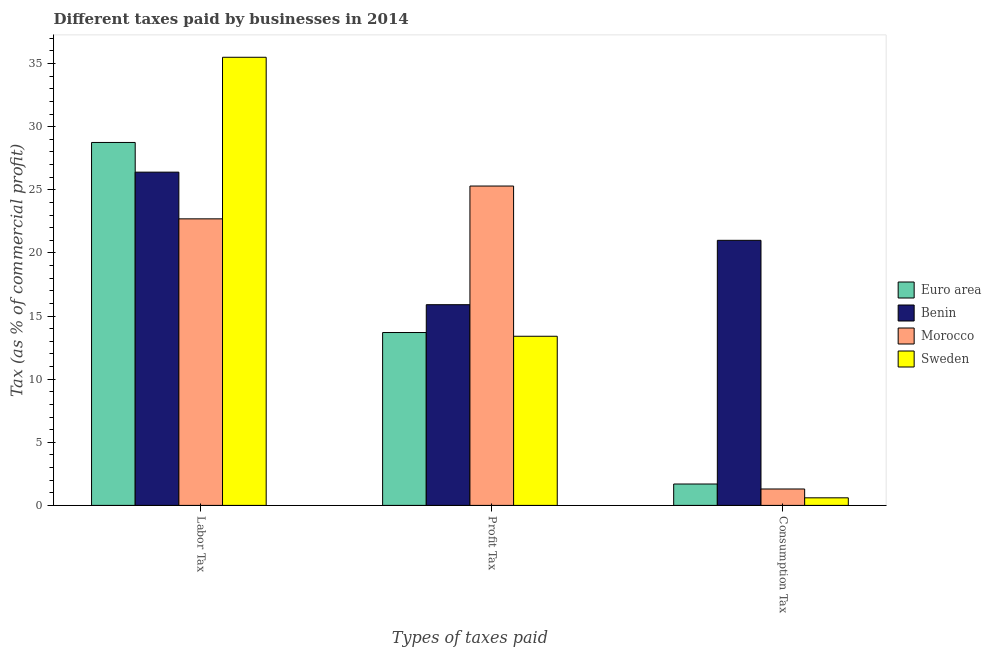Are the number of bars per tick equal to the number of legend labels?
Your response must be concise. Yes. How many bars are there on the 2nd tick from the left?
Offer a very short reply. 4. What is the label of the 3rd group of bars from the left?
Provide a succinct answer. Consumption Tax. What is the percentage of labor tax in Benin?
Give a very brief answer. 26.4. Across all countries, what is the minimum percentage of profit tax?
Give a very brief answer. 13.4. In which country was the percentage of profit tax maximum?
Keep it short and to the point. Morocco. What is the total percentage of consumption tax in the graph?
Your answer should be compact. 24.59. What is the difference between the percentage of profit tax in Sweden and that in Euro area?
Provide a short and direct response. -0.29. What is the difference between the percentage of profit tax in Sweden and the percentage of consumption tax in Morocco?
Your answer should be very brief. 12.1. What is the average percentage of labor tax per country?
Your answer should be compact. 28.34. What is the difference between the percentage of labor tax and percentage of profit tax in Morocco?
Make the answer very short. -2.6. In how many countries, is the percentage of profit tax greater than 19 %?
Your answer should be compact. 1. What is the ratio of the percentage of consumption tax in Sweden to that in Morocco?
Give a very brief answer. 0.46. Is the percentage of profit tax in Euro area less than that in Sweden?
Your answer should be compact. No. What is the difference between the highest and the second highest percentage of labor tax?
Provide a succinct answer. 6.75. What is the difference between the highest and the lowest percentage of labor tax?
Keep it short and to the point. 12.8. What does the 2nd bar from the left in Profit Tax represents?
Give a very brief answer. Benin. What does the 1st bar from the right in Labor Tax represents?
Your answer should be compact. Sweden. Is it the case that in every country, the sum of the percentage of labor tax and percentage of profit tax is greater than the percentage of consumption tax?
Your answer should be compact. Yes. How many bars are there?
Offer a terse response. 12. Are all the bars in the graph horizontal?
Your answer should be very brief. No. What is the difference between two consecutive major ticks on the Y-axis?
Your answer should be very brief. 5. Are the values on the major ticks of Y-axis written in scientific E-notation?
Your answer should be compact. No. Does the graph contain any zero values?
Provide a succinct answer. No. How are the legend labels stacked?
Offer a very short reply. Vertical. What is the title of the graph?
Offer a very short reply. Different taxes paid by businesses in 2014. What is the label or title of the X-axis?
Your answer should be very brief. Types of taxes paid. What is the label or title of the Y-axis?
Your response must be concise. Tax (as % of commercial profit). What is the Tax (as % of commercial profit) in Euro area in Labor Tax?
Provide a short and direct response. 28.75. What is the Tax (as % of commercial profit) in Benin in Labor Tax?
Your response must be concise. 26.4. What is the Tax (as % of commercial profit) in Morocco in Labor Tax?
Provide a short and direct response. 22.7. What is the Tax (as % of commercial profit) of Sweden in Labor Tax?
Your answer should be very brief. 35.5. What is the Tax (as % of commercial profit) of Euro area in Profit Tax?
Offer a terse response. 13.69. What is the Tax (as % of commercial profit) of Morocco in Profit Tax?
Ensure brevity in your answer.  25.3. What is the Tax (as % of commercial profit) in Sweden in Profit Tax?
Ensure brevity in your answer.  13.4. What is the Tax (as % of commercial profit) of Euro area in Consumption Tax?
Ensure brevity in your answer.  1.69. Across all Types of taxes paid, what is the maximum Tax (as % of commercial profit) of Euro area?
Offer a terse response. 28.75. Across all Types of taxes paid, what is the maximum Tax (as % of commercial profit) in Benin?
Make the answer very short. 26.4. Across all Types of taxes paid, what is the maximum Tax (as % of commercial profit) of Morocco?
Your response must be concise. 25.3. Across all Types of taxes paid, what is the maximum Tax (as % of commercial profit) in Sweden?
Offer a very short reply. 35.5. Across all Types of taxes paid, what is the minimum Tax (as % of commercial profit) of Euro area?
Ensure brevity in your answer.  1.69. Across all Types of taxes paid, what is the minimum Tax (as % of commercial profit) in Benin?
Ensure brevity in your answer.  15.9. Across all Types of taxes paid, what is the minimum Tax (as % of commercial profit) in Sweden?
Give a very brief answer. 0.6. What is the total Tax (as % of commercial profit) in Euro area in the graph?
Make the answer very short. 44.14. What is the total Tax (as % of commercial profit) of Benin in the graph?
Your answer should be compact. 63.3. What is the total Tax (as % of commercial profit) of Morocco in the graph?
Provide a succinct answer. 49.3. What is the total Tax (as % of commercial profit) in Sweden in the graph?
Give a very brief answer. 49.5. What is the difference between the Tax (as % of commercial profit) in Euro area in Labor Tax and that in Profit Tax?
Keep it short and to the point. 15.06. What is the difference between the Tax (as % of commercial profit) in Benin in Labor Tax and that in Profit Tax?
Your answer should be compact. 10.5. What is the difference between the Tax (as % of commercial profit) in Morocco in Labor Tax and that in Profit Tax?
Your answer should be very brief. -2.6. What is the difference between the Tax (as % of commercial profit) of Sweden in Labor Tax and that in Profit Tax?
Ensure brevity in your answer.  22.1. What is the difference between the Tax (as % of commercial profit) in Euro area in Labor Tax and that in Consumption Tax?
Keep it short and to the point. 27.06. What is the difference between the Tax (as % of commercial profit) in Benin in Labor Tax and that in Consumption Tax?
Make the answer very short. 5.4. What is the difference between the Tax (as % of commercial profit) in Morocco in Labor Tax and that in Consumption Tax?
Give a very brief answer. 21.4. What is the difference between the Tax (as % of commercial profit) in Sweden in Labor Tax and that in Consumption Tax?
Your response must be concise. 34.9. What is the difference between the Tax (as % of commercial profit) of Euro area in Profit Tax and that in Consumption Tax?
Offer a terse response. 12. What is the difference between the Tax (as % of commercial profit) in Sweden in Profit Tax and that in Consumption Tax?
Your response must be concise. 12.8. What is the difference between the Tax (as % of commercial profit) in Euro area in Labor Tax and the Tax (as % of commercial profit) in Benin in Profit Tax?
Your answer should be compact. 12.85. What is the difference between the Tax (as % of commercial profit) in Euro area in Labor Tax and the Tax (as % of commercial profit) in Morocco in Profit Tax?
Your response must be concise. 3.45. What is the difference between the Tax (as % of commercial profit) in Euro area in Labor Tax and the Tax (as % of commercial profit) in Sweden in Profit Tax?
Ensure brevity in your answer.  15.35. What is the difference between the Tax (as % of commercial profit) in Morocco in Labor Tax and the Tax (as % of commercial profit) in Sweden in Profit Tax?
Offer a terse response. 9.3. What is the difference between the Tax (as % of commercial profit) of Euro area in Labor Tax and the Tax (as % of commercial profit) of Benin in Consumption Tax?
Offer a very short reply. 7.75. What is the difference between the Tax (as % of commercial profit) in Euro area in Labor Tax and the Tax (as % of commercial profit) in Morocco in Consumption Tax?
Ensure brevity in your answer.  27.45. What is the difference between the Tax (as % of commercial profit) of Euro area in Labor Tax and the Tax (as % of commercial profit) of Sweden in Consumption Tax?
Give a very brief answer. 28.15. What is the difference between the Tax (as % of commercial profit) in Benin in Labor Tax and the Tax (as % of commercial profit) in Morocco in Consumption Tax?
Your answer should be very brief. 25.1. What is the difference between the Tax (as % of commercial profit) of Benin in Labor Tax and the Tax (as % of commercial profit) of Sweden in Consumption Tax?
Offer a terse response. 25.8. What is the difference between the Tax (as % of commercial profit) of Morocco in Labor Tax and the Tax (as % of commercial profit) of Sweden in Consumption Tax?
Give a very brief answer. 22.1. What is the difference between the Tax (as % of commercial profit) in Euro area in Profit Tax and the Tax (as % of commercial profit) in Benin in Consumption Tax?
Offer a very short reply. -7.31. What is the difference between the Tax (as % of commercial profit) in Euro area in Profit Tax and the Tax (as % of commercial profit) in Morocco in Consumption Tax?
Give a very brief answer. 12.39. What is the difference between the Tax (as % of commercial profit) in Euro area in Profit Tax and the Tax (as % of commercial profit) in Sweden in Consumption Tax?
Your answer should be compact. 13.09. What is the difference between the Tax (as % of commercial profit) in Benin in Profit Tax and the Tax (as % of commercial profit) in Morocco in Consumption Tax?
Make the answer very short. 14.6. What is the difference between the Tax (as % of commercial profit) in Benin in Profit Tax and the Tax (as % of commercial profit) in Sweden in Consumption Tax?
Offer a very short reply. 15.3. What is the difference between the Tax (as % of commercial profit) in Morocco in Profit Tax and the Tax (as % of commercial profit) in Sweden in Consumption Tax?
Provide a succinct answer. 24.7. What is the average Tax (as % of commercial profit) of Euro area per Types of taxes paid?
Give a very brief answer. 14.71. What is the average Tax (as % of commercial profit) in Benin per Types of taxes paid?
Offer a terse response. 21.1. What is the average Tax (as % of commercial profit) of Morocco per Types of taxes paid?
Offer a very short reply. 16.43. What is the average Tax (as % of commercial profit) of Sweden per Types of taxes paid?
Your answer should be very brief. 16.5. What is the difference between the Tax (as % of commercial profit) in Euro area and Tax (as % of commercial profit) in Benin in Labor Tax?
Make the answer very short. 2.35. What is the difference between the Tax (as % of commercial profit) of Euro area and Tax (as % of commercial profit) of Morocco in Labor Tax?
Ensure brevity in your answer.  6.05. What is the difference between the Tax (as % of commercial profit) in Euro area and Tax (as % of commercial profit) in Sweden in Labor Tax?
Provide a succinct answer. -6.75. What is the difference between the Tax (as % of commercial profit) of Morocco and Tax (as % of commercial profit) of Sweden in Labor Tax?
Offer a very short reply. -12.8. What is the difference between the Tax (as % of commercial profit) in Euro area and Tax (as % of commercial profit) in Benin in Profit Tax?
Offer a terse response. -2.21. What is the difference between the Tax (as % of commercial profit) of Euro area and Tax (as % of commercial profit) of Morocco in Profit Tax?
Make the answer very short. -11.61. What is the difference between the Tax (as % of commercial profit) of Euro area and Tax (as % of commercial profit) of Sweden in Profit Tax?
Keep it short and to the point. 0.29. What is the difference between the Tax (as % of commercial profit) in Benin and Tax (as % of commercial profit) in Sweden in Profit Tax?
Your response must be concise. 2.5. What is the difference between the Tax (as % of commercial profit) in Euro area and Tax (as % of commercial profit) in Benin in Consumption Tax?
Make the answer very short. -19.31. What is the difference between the Tax (as % of commercial profit) in Euro area and Tax (as % of commercial profit) in Morocco in Consumption Tax?
Make the answer very short. 0.39. What is the difference between the Tax (as % of commercial profit) in Euro area and Tax (as % of commercial profit) in Sweden in Consumption Tax?
Give a very brief answer. 1.09. What is the difference between the Tax (as % of commercial profit) in Benin and Tax (as % of commercial profit) in Morocco in Consumption Tax?
Your answer should be very brief. 19.7. What is the difference between the Tax (as % of commercial profit) of Benin and Tax (as % of commercial profit) of Sweden in Consumption Tax?
Provide a succinct answer. 20.4. What is the ratio of the Tax (as % of commercial profit) in Euro area in Labor Tax to that in Profit Tax?
Provide a short and direct response. 2.1. What is the ratio of the Tax (as % of commercial profit) in Benin in Labor Tax to that in Profit Tax?
Keep it short and to the point. 1.66. What is the ratio of the Tax (as % of commercial profit) in Morocco in Labor Tax to that in Profit Tax?
Provide a succinct answer. 0.9. What is the ratio of the Tax (as % of commercial profit) of Sweden in Labor Tax to that in Profit Tax?
Make the answer very short. 2.65. What is the ratio of the Tax (as % of commercial profit) of Euro area in Labor Tax to that in Consumption Tax?
Your answer should be compact. 16.97. What is the ratio of the Tax (as % of commercial profit) in Benin in Labor Tax to that in Consumption Tax?
Your response must be concise. 1.26. What is the ratio of the Tax (as % of commercial profit) of Morocco in Labor Tax to that in Consumption Tax?
Your response must be concise. 17.46. What is the ratio of the Tax (as % of commercial profit) of Sweden in Labor Tax to that in Consumption Tax?
Make the answer very short. 59.17. What is the ratio of the Tax (as % of commercial profit) in Euro area in Profit Tax to that in Consumption Tax?
Ensure brevity in your answer.  8.08. What is the ratio of the Tax (as % of commercial profit) of Benin in Profit Tax to that in Consumption Tax?
Keep it short and to the point. 0.76. What is the ratio of the Tax (as % of commercial profit) of Morocco in Profit Tax to that in Consumption Tax?
Provide a succinct answer. 19.46. What is the ratio of the Tax (as % of commercial profit) in Sweden in Profit Tax to that in Consumption Tax?
Offer a terse response. 22.33. What is the difference between the highest and the second highest Tax (as % of commercial profit) of Euro area?
Your answer should be compact. 15.06. What is the difference between the highest and the second highest Tax (as % of commercial profit) in Benin?
Offer a very short reply. 5.4. What is the difference between the highest and the second highest Tax (as % of commercial profit) of Sweden?
Make the answer very short. 22.1. What is the difference between the highest and the lowest Tax (as % of commercial profit) in Euro area?
Make the answer very short. 27.06. What is the difference between the highest and the lowest Tax (as % of commercial profit) of Morocco?
Make the answer very short. 24. What is the difference between the highest and the lowest Tax (as % of commercial profit) of Sweden?
Give a very brief answer. 34.9. 